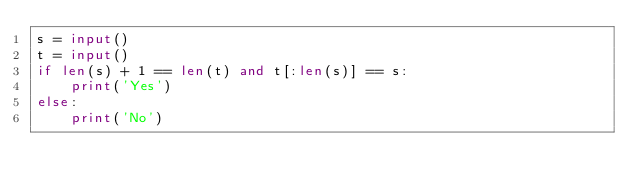<code> <loc_0><loc_0><loc_500><loc_500><_Python_>s = input()
t = input()
if len(s) + 1 == len(t) and t[:len(s)] == s:
    print('Yes')
else:
    print('No')</code> 